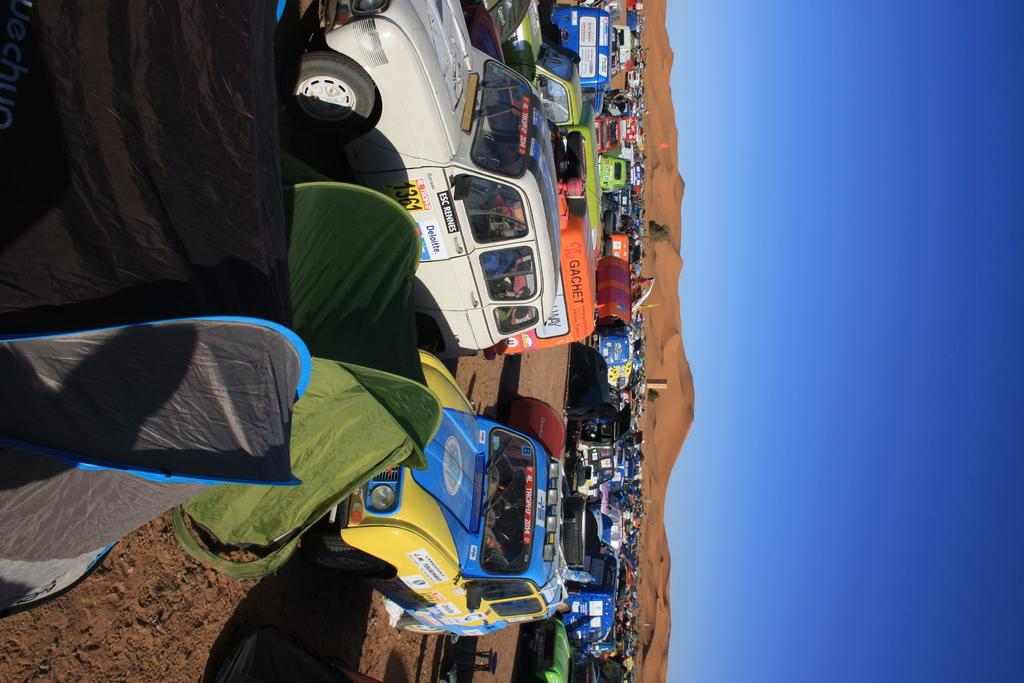What types of objects are present in the image? There are vehicles and tents in the image. What can be seen on the right side of the image? There is sand on the right side of the image. What is visible in the background of the image? The sky is visible in the image. What type of basin can be seen in the image? There is no basin present in the image. How does friction affect the movement of the vehicles in the image? The image does not provide information about the movement of the vehicles, so it is impossible to determine how friction might affect them. 